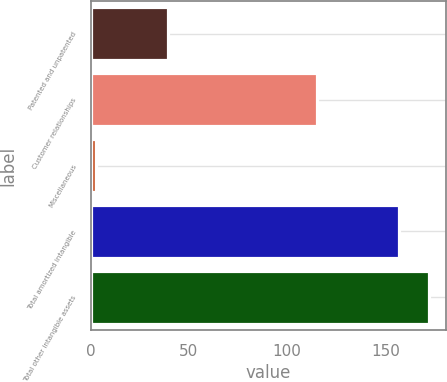Convert chart to OTSL. <chart><loc_0><loc_0><loc_500><loc_500><bar_chart><fcel>Patented and unpatented<fcel>Customer relationships<fcel>Miscellaneous<fcel>Total amortized intangible<fcel>Total other intangible assets<nl><fcel>39.1<fcel>115.1<fcel>2.5<fcel>156.7<fcel>172.12<nl></chart> 